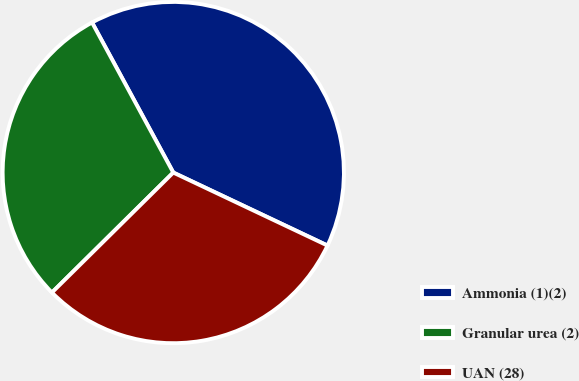<chart> <loc_0><loc_0><loc_500><loc_500><pie_chart><fcel>Ammonia (1)(2)<fcel>Granular urea (2)<fcel>UAN (28)<nl><fcel>39.93%<fcel>29.51%<fcel>30.55%<nl></chart> 